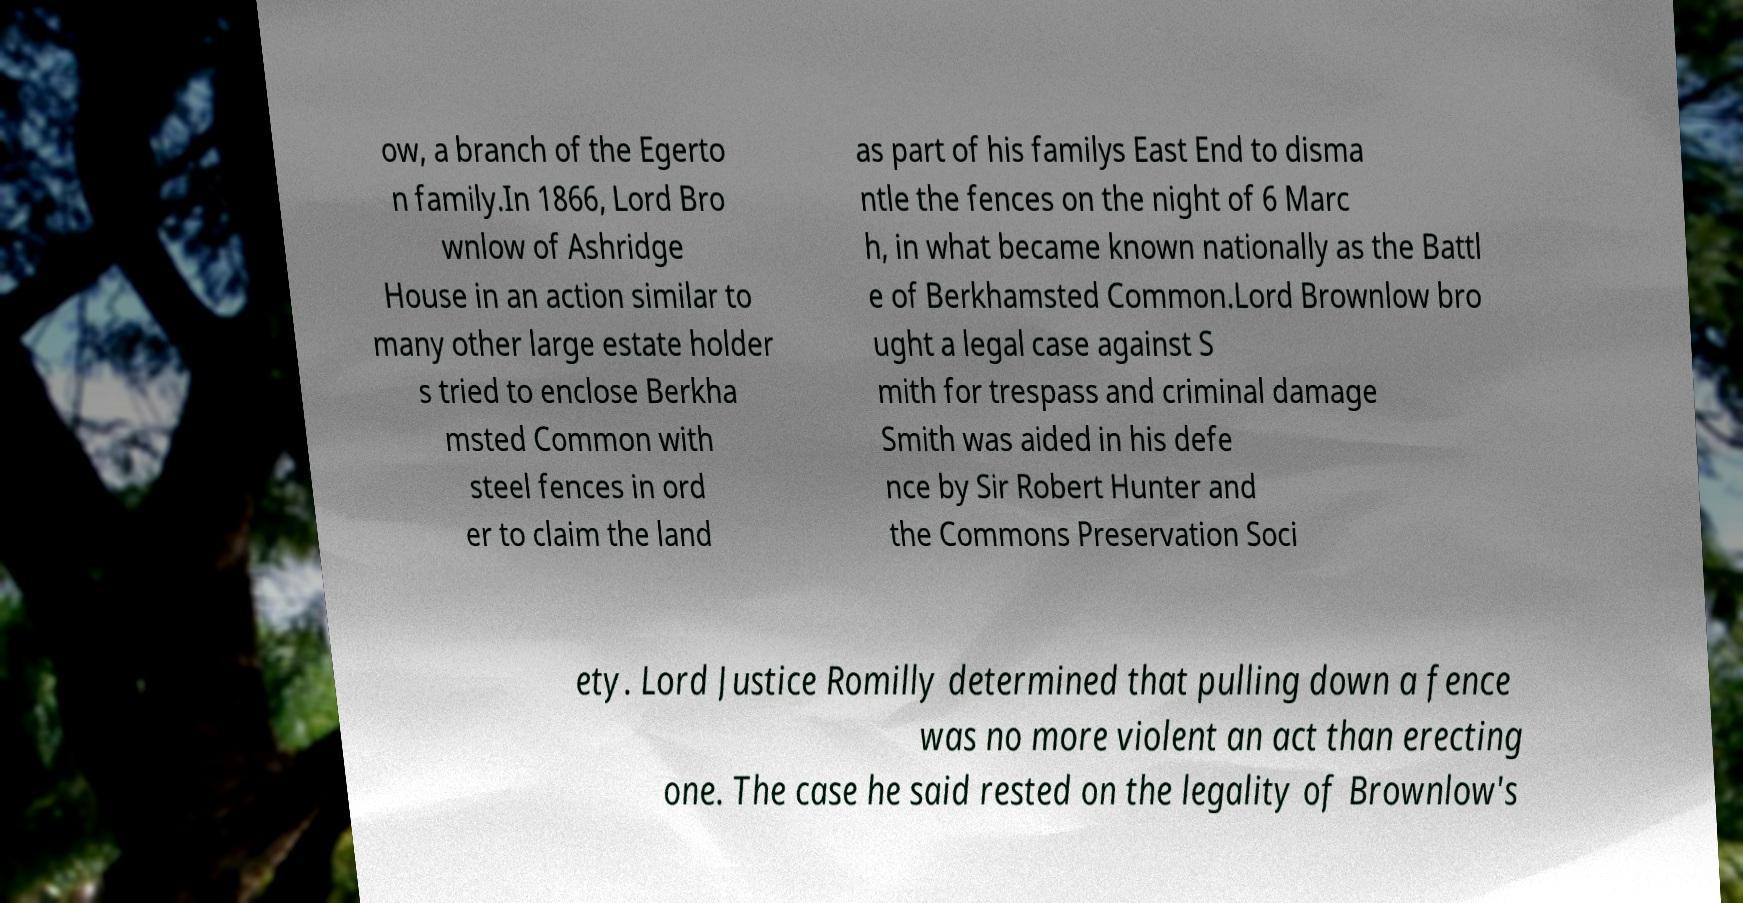Could you extract and type out the text from this image? ow, a branch of the Egerto n family.In 1866, Lord Bro wnlow of Ashridge House in an action similar to many other large estate holder s tried to enclose Berkha msted Common with steel fences in ord er to claim the land as part of his familys East End to disma ntle the fences on the night of 6 Marc h, in what became known nationally as the Battl e of Berkhamsted Common.Lord Brownlow bro ught a legal case against S mith for trespass and criminal damage Smith was aided in his defe nce by Sir Robert Hunter and the Commons Preservation Soci ety. Lord Justice Romilly determined that pulling down a fence was no more violent an act than erecting one. The case he said rested on the legality of Brownlow's 